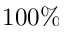<formula> <loc_0><loc_0><loc_500><loc_500>1 0 0 \%</formula> 